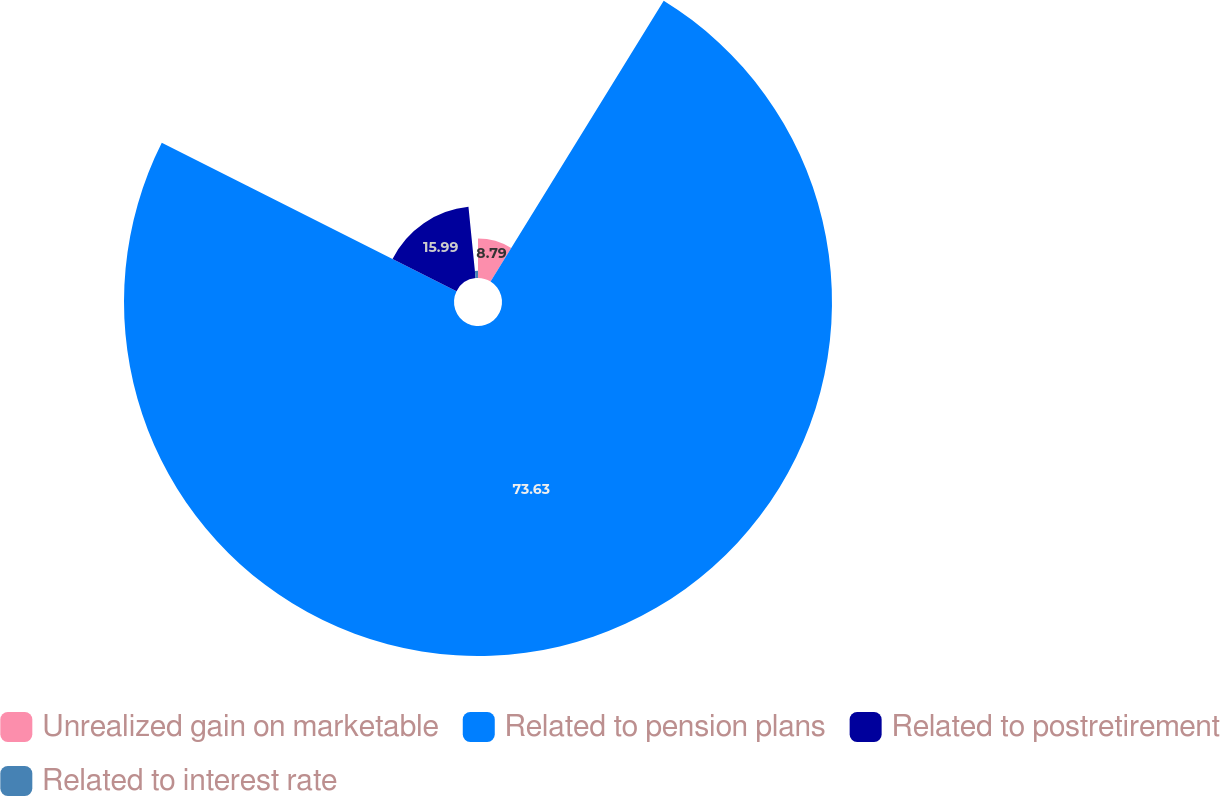Convert chart to OTSL. <chart><loc_0><loc_0><loc_500><loc_500><pie_chart><fcel>Unrealized gain on marketable<fcel>Related to pension plans<fcel>Related to postretirement<fcel>Related to interest rate<nl><fcel>8.79%<fcel>73.63%<fcel>15.99%<fcel>1.59%<nl></chart> 